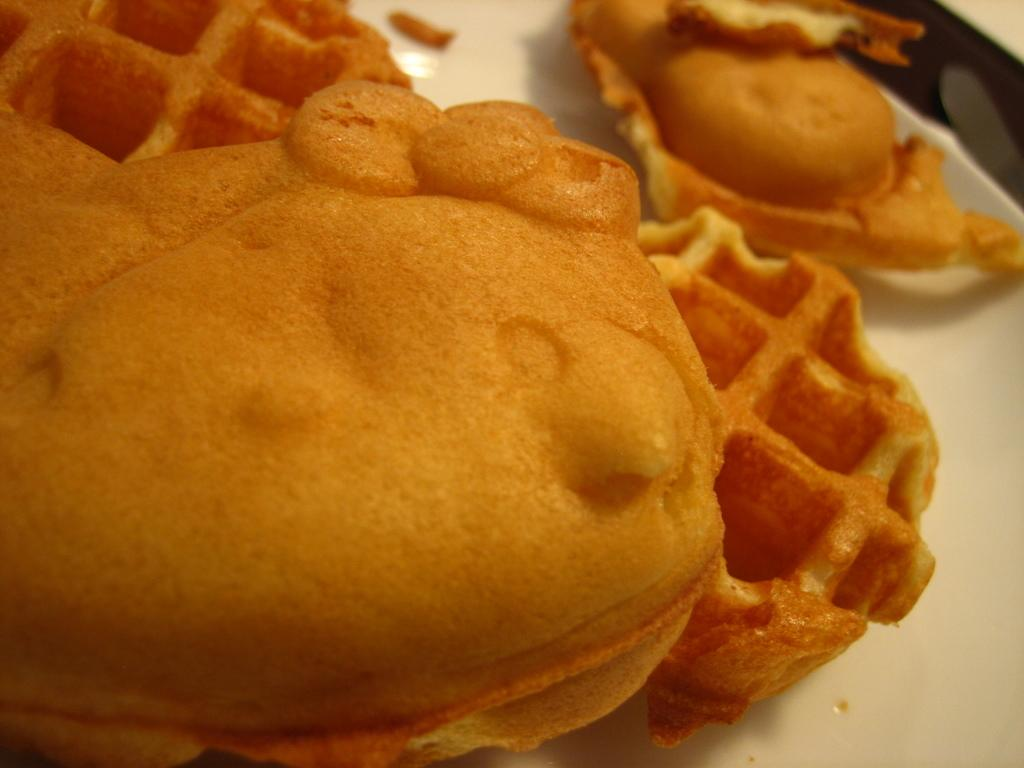What is present on the plate in the image? There is a food item on the plate in the image. Can you describe the plate itself? The facts provided do not give any details about the plate, so we cannot describe it further. What type of tent can be seen in the background of the image? There is no tent present in the image. 